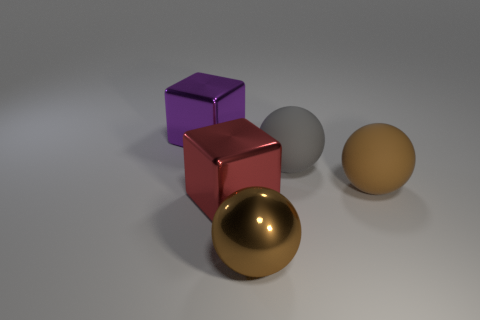Add 4 large red cubes. How many objects exist? 9 Subtract all cubes. How many objects are left? 3 Add 5 brown matte objects. How many brown matte objects are left? 6 Add 5 purple objects. How many purple objects exist? 6 Subtract 0 gray blocks. How many objects are left? 5 Subtract all tiny brown spheres. Subtract all spheres. How many objects are left? 2 